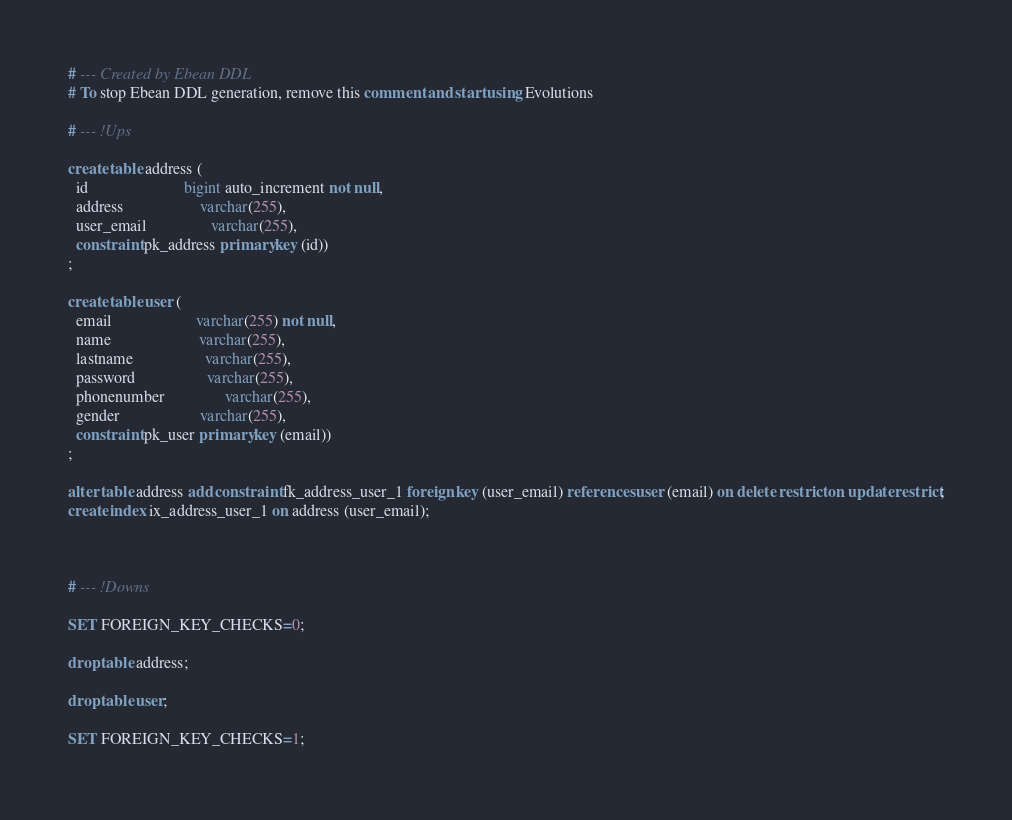Convert code to text. <code><loc_0><loc_0><loc_500><loc_500><_SQL_># --- Created by Ebean DDL
# To stop Ebean DDL generation, remove this comment and start using Evolutions

# --- !Ups

create table address (
  id                        bigint auto_increment not null,
  address                   varchar(255),
  user_email                varchar(255),
  constraint pk_address primary key (id))
;

create table user (
  email                     varchar(255) not null,
  name                      varchar(255),
  lastname                  varchar(255),
  password                  varchar(255),
  phonenumber               varchar(255),
  gender                    varchar(255),
  constraint pk_user primary key (email))
;

alter table address add constraint fk_address_user_1 foreign key (user_email) references user (email) on delete restrict on update restrict;
create index ix_address_user_1 on address (user_email);



# --- !Downs

SET FOREIGN_KEY_CHECKS=0;

drop table address;

drop table user;

SET FOREIGN_KEY_CHECKS=1;

</code> 